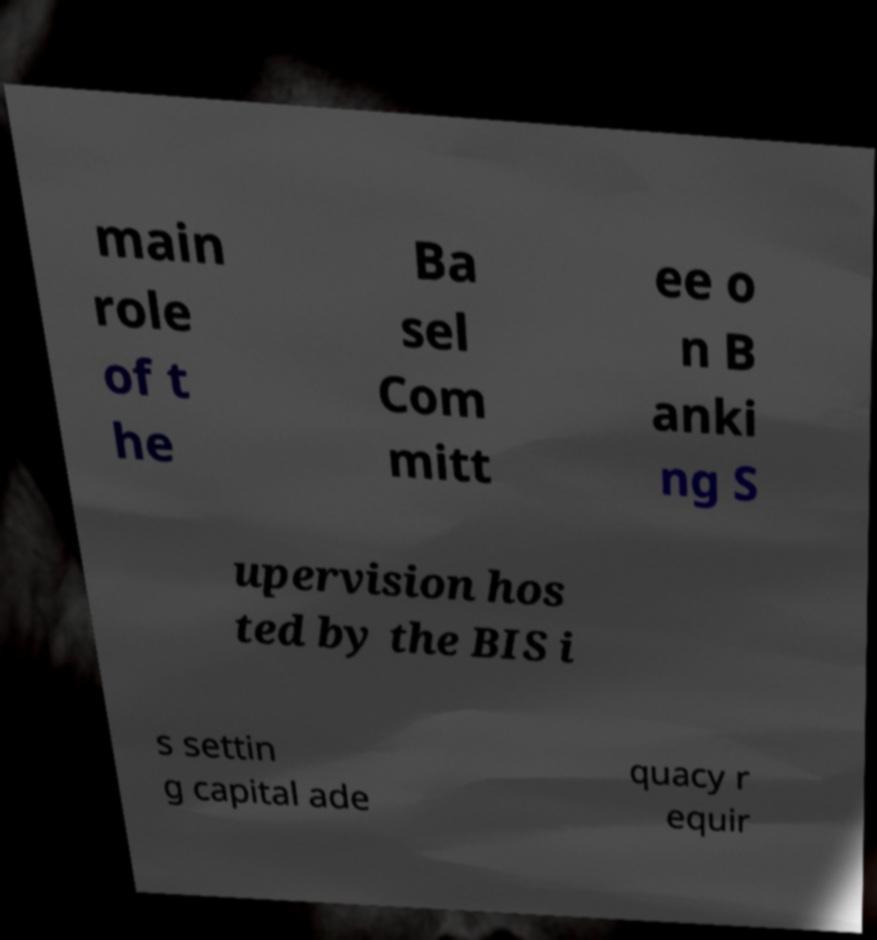Please read and relay the text visible in this image. What does it say? main role of t he Ba sel Com mitt ee o n B anki ng S upervision hos ted by the BIS i s settin g capital ade quacy r equir 